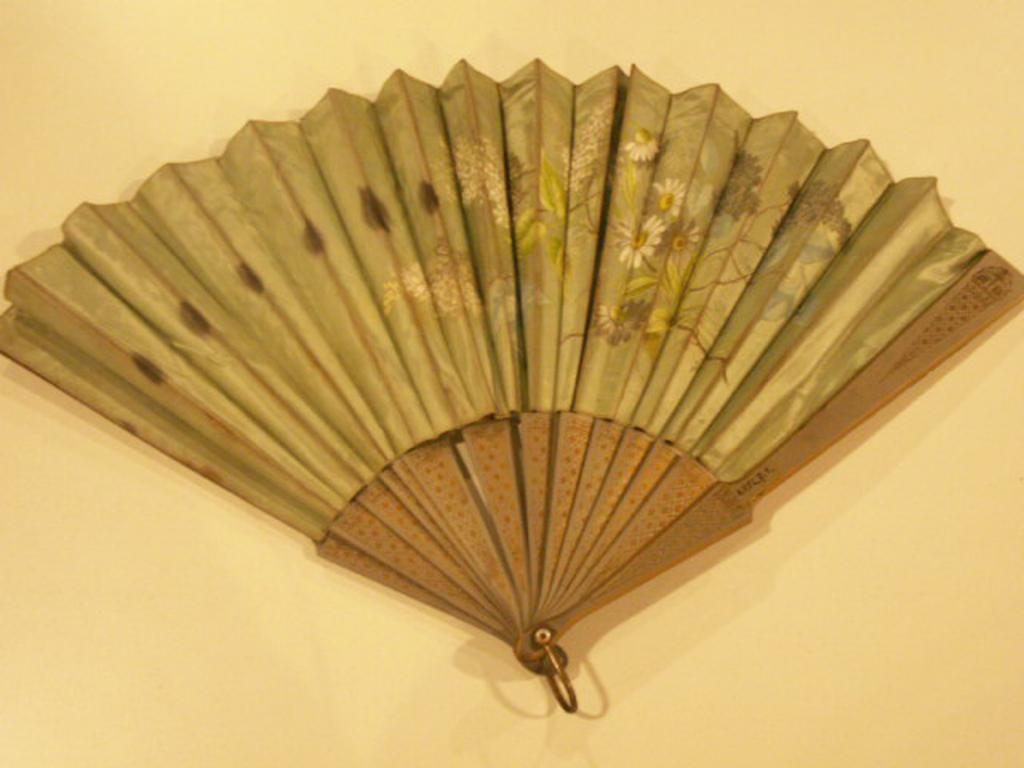What object can be seen in the image? There is a hand fan in the image. Where is the hand fan located? The hand fan is placed on a plain surface. How many spiders are crawling on the hand fan in the image? There are no spiders present in the image; it only features a hand fan placed on a plain surface. What type of thrill can be experienced by the hand fan in the image? The hand fan is an inanimate object and cannot experience any emotions or thrills. 